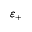Convert formula to latex. <formula><loc_0><loc_0><loc_500><loc_500>\varepsilon _ { + }</formula> 